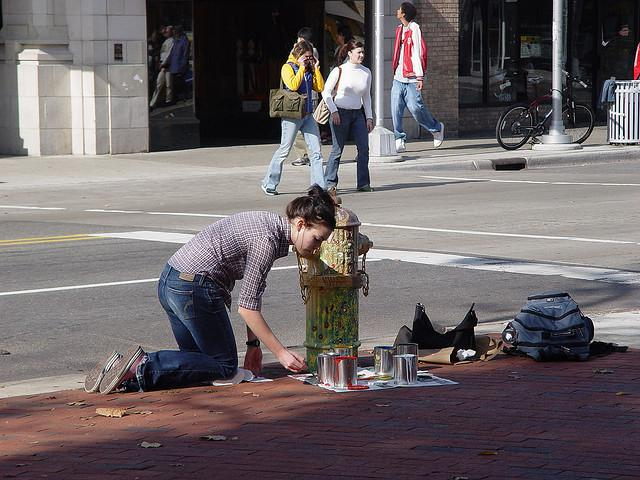What kind of brush is being used? paint 